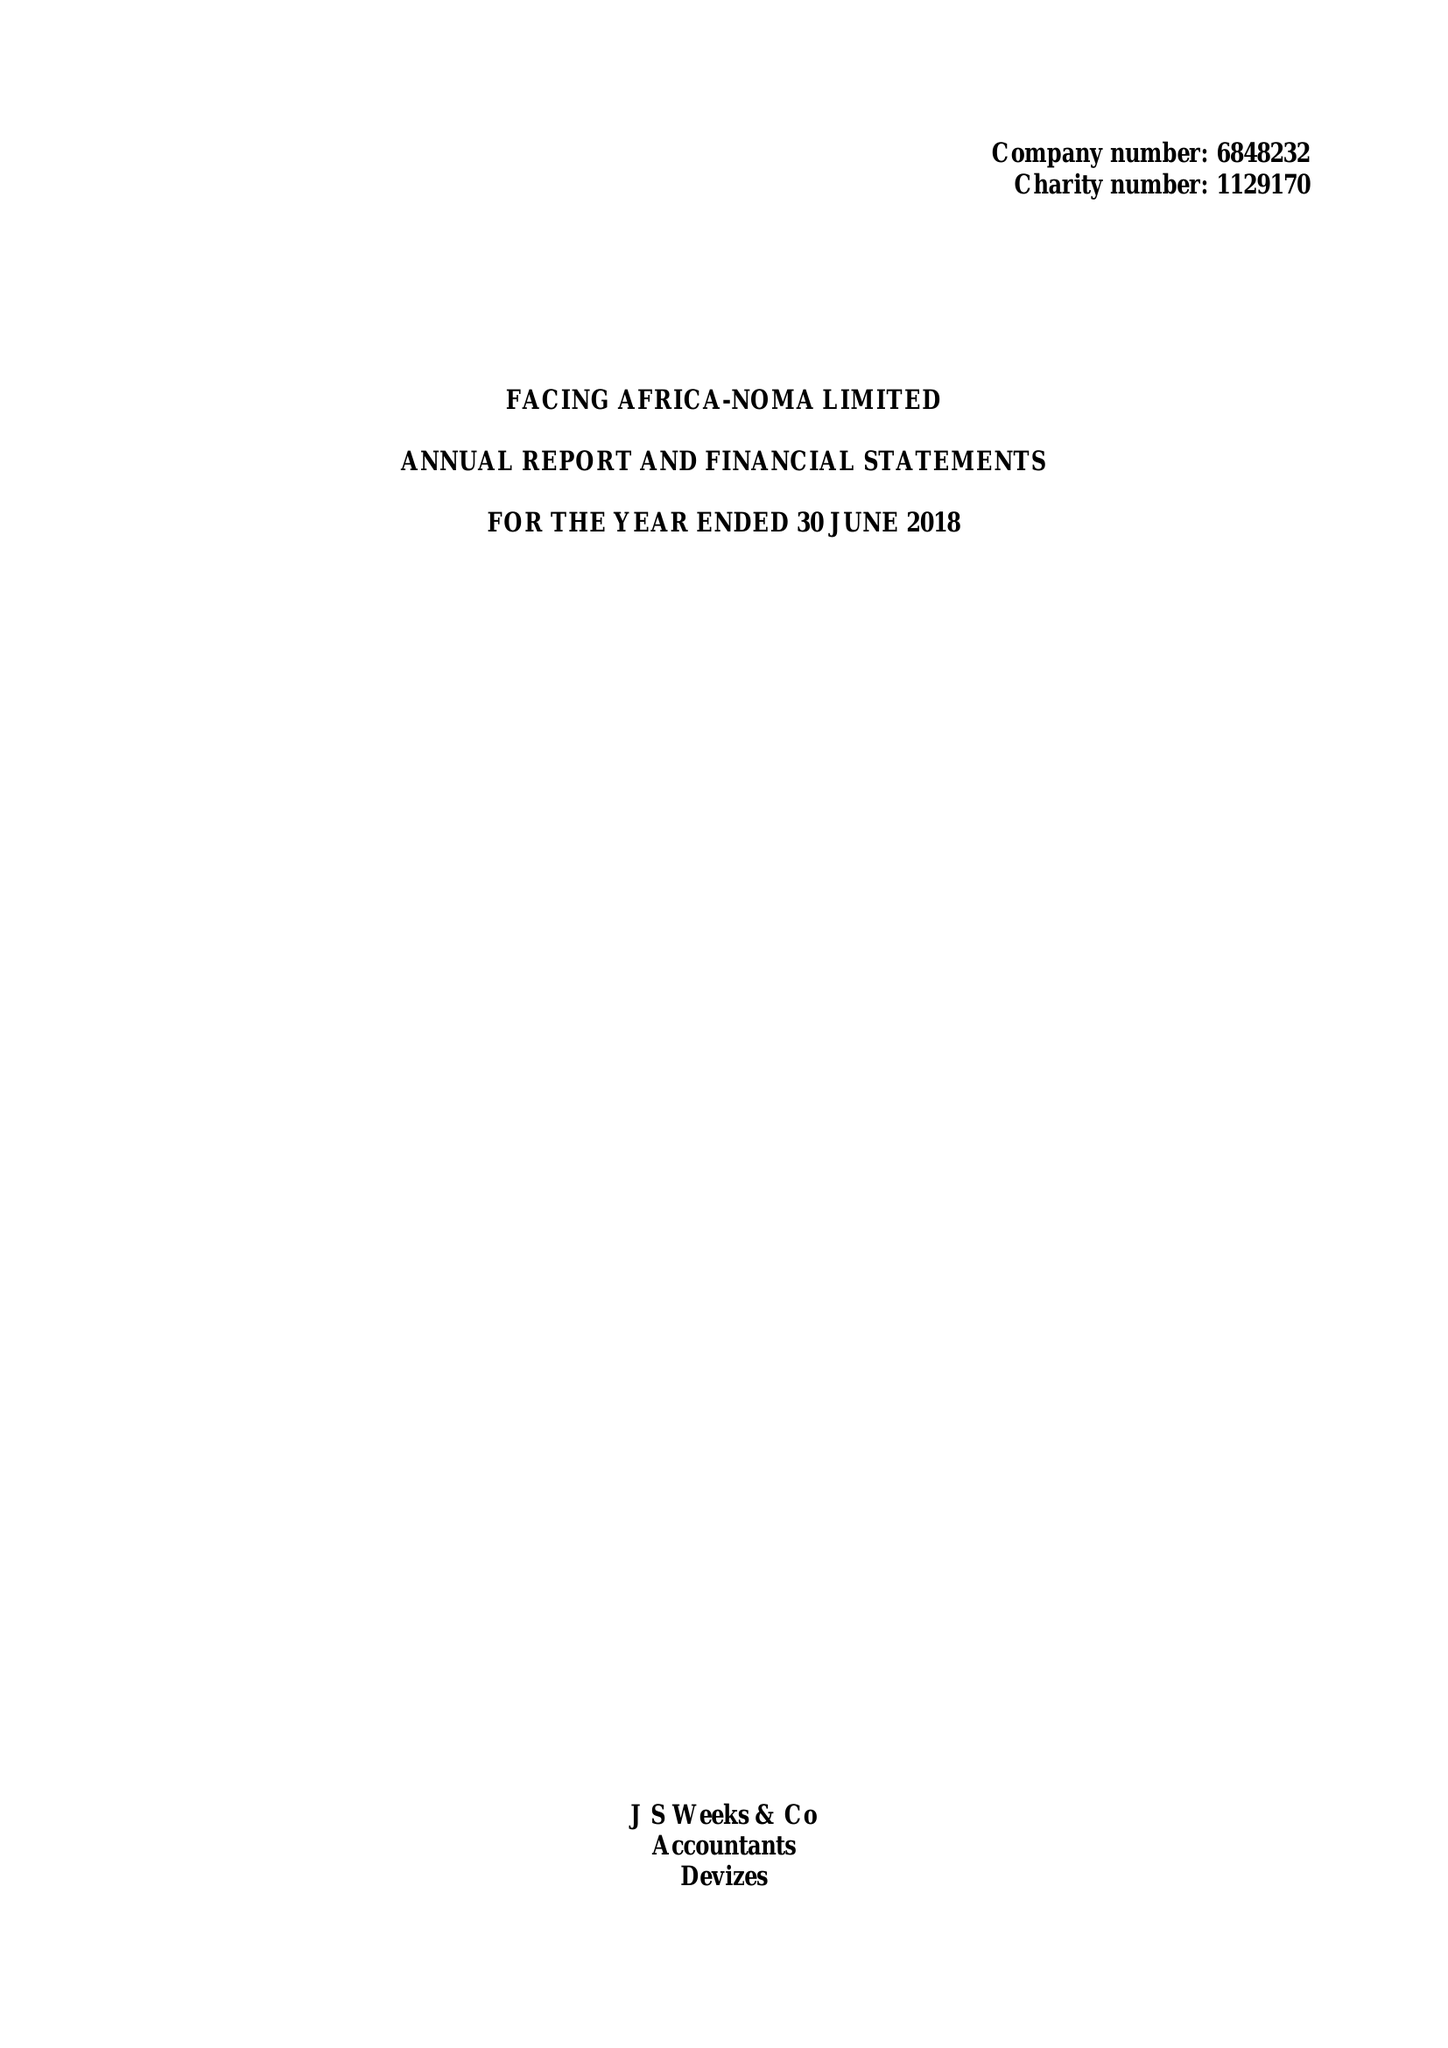What is the value for the charity_name?
Answer the question using a single word or phrase. Facing Africa Noma Ltd. 